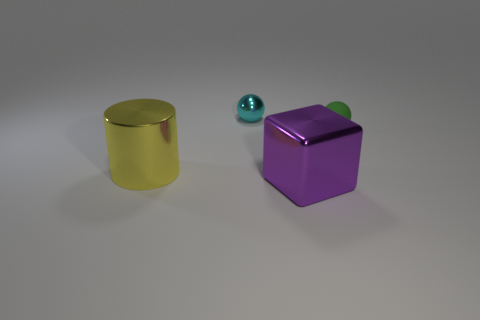There is a big purple shiny object; are there any cyan things in front of it?
Your response must be concise. No. Do the purple object and the metal object that is behind the large yellow object have the same size?
Make the answer very short. No. Are there any metallic cylinders of the same color as the small rubber sphere?
Your response must be concise. No. Is there a gray object of the same shape as the yellow shiny object?
Provide a succinct answer. No. The thing that is left of the purple thing and behind the large metal cylinder has what shape?
Give a very brief answer. Sphere. What number of big yellow objects have the same material as the yellow cylinder?
Ensure brevity in your answer.  0. Is the number of tiny green things left of the large yellow metal cylinder less than the number of cylinders?
Your answer should be very brief. Yes. Is there a purple object that is left of the shiny thing that is in front of the large yellow thing?
Offer a very short reply. No. Is there anything else that is the same shape as the yellow metal object?
Provide a succinct answer. No. Is the size of the purple block the same as the cyan ball?
Keep it short and to the point. No. 